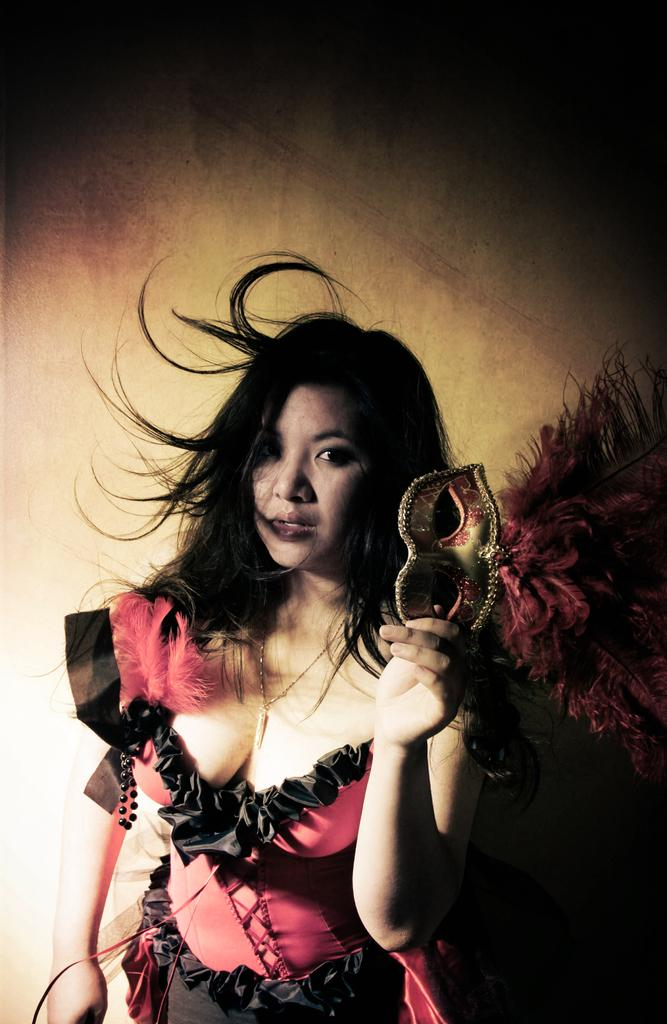Who is present in the image? There is a woman in the image. What is the woman doing in the image? The woman is standing in the image. What object is the woman holding in her hand? The woman is holding a mask in her hand. What type of writing can be seen on the mask the woman is holding? There is no writing visible on the mask the woman is holding in the image. 